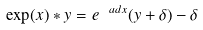Convert formula to latex. <formula><loc_0><loc_0><loc_500><loc_500>\exp ( x ) \ast y = e ^ { \ a d x } ( y + \delta ) - \delta</formula> 